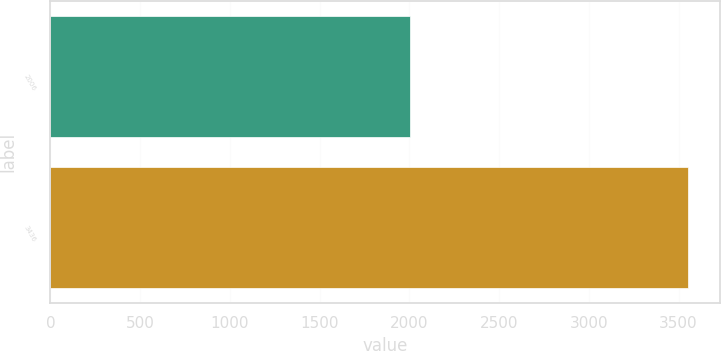<chart> <loc_0><loc_0><loc_500><loc_500><bar_chart><fcel>2006<fcel>3436<nl><fcel>2005<fcel>3552<nl></chart> 